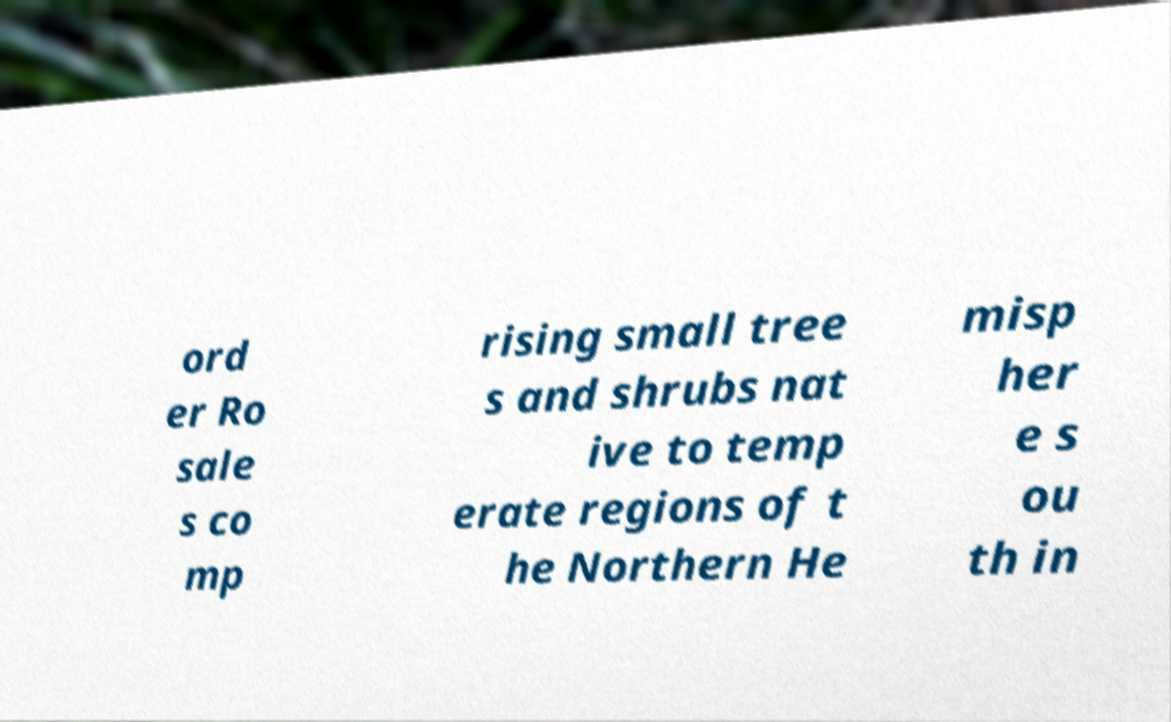There's text embedded in this image that I need extracted. Can you transcribe it verbatim? ord er Ro sale s co mp rising small tree s and shrubs nat ive to temp erate regions of t he Northern He misp her e s ou th in 